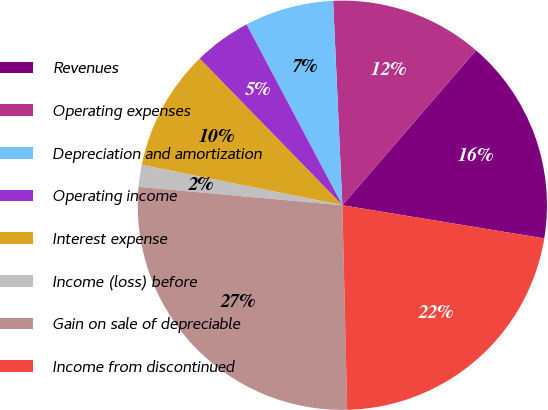Convert chart to OTSL. <chart><loc_0><loc_0><loc_500><loc_500><pie_chart><fcel>Revenues<fcel>Operating expenses<fcel>Depreciation and amortization<fcel>Operating income<fcel>Interest expense<fcel>Income (loss) before<fcel>Gain on sale of depreciable<fcel>Income from discontinued<nl><fcel>16.26%<fcel>12.05%<fcel>7.04%<fcel>4.53%<fcel>9.55%<fcel>1.73%<fcel>26.81%<fcel>22.03%<nl></chart> 